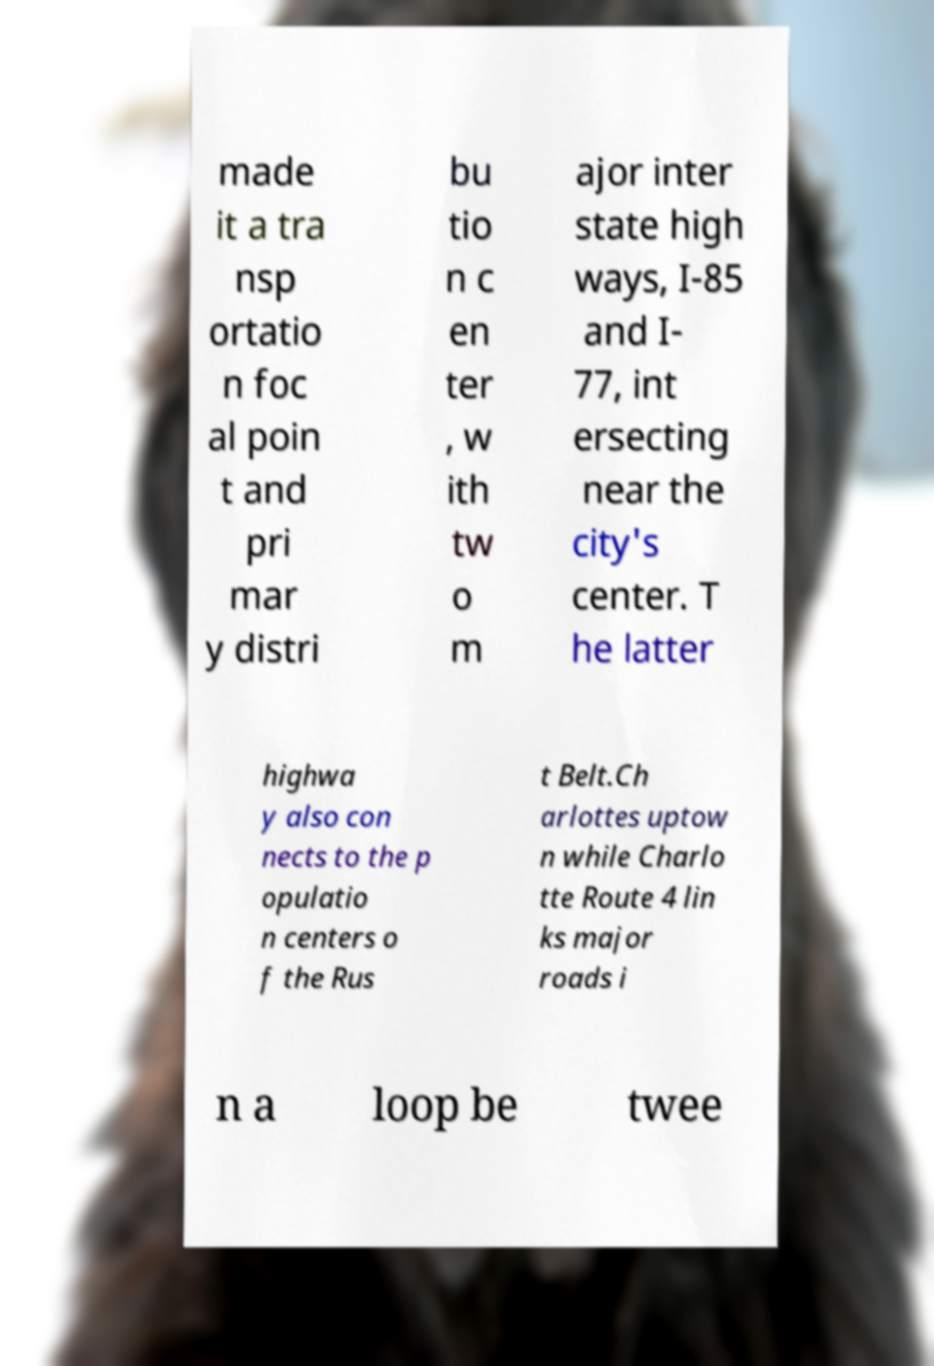Can you accurately transcribe the text from the provided image for me? made it a tra nsp ortatio n foc al poin t and pri mar y distri bu tio n c en ter , w ith tw o m ajor inter state high ways, I-85 and I- 77, int ersecting near the city's center. T he latter highwa y also con nects to the p opulatio n centers o f the Rus t Belt.Ch arlottes uptow n while Charlo tte Route 4 lin ks major roads i n a loop be twee 